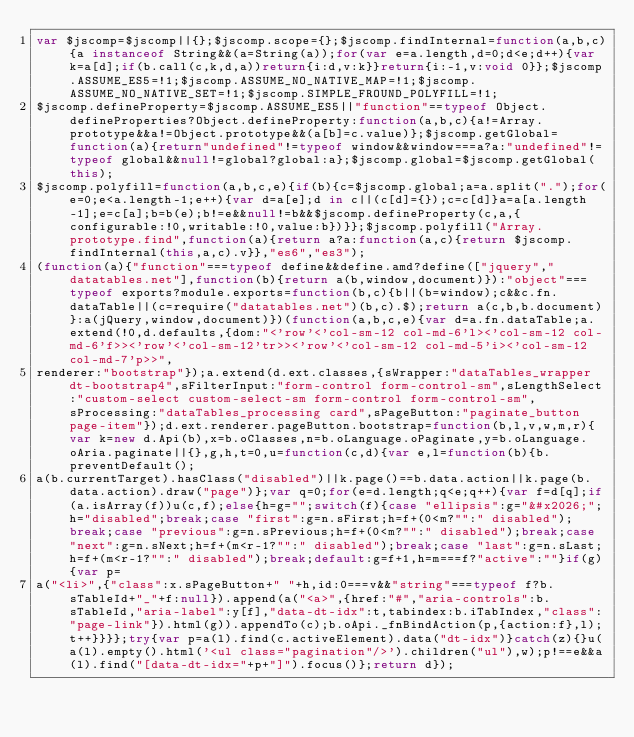<code> <loc_0><loc_0><loc_500><loc_500><_JavaScript_>var $jscomp=$jscomp||{};$jscomp.scope={};$jscomp.findInternal=function(a,b,c){a instanceof String&&(a=String(a));for(var e=a.length,d=0;d<e;d++){var k=a[d];if(b.call(c,k,d,a))return{i:d,v:k}}return{i:-1,v:void 0}};$jscomp.ASSUME_ES5=!1;$jscomp.ASSUME_NO_NATIVE_MAP=!1;$jscomp.ASSUME_NO_NATIVE_SET=!1;$jscomp.SIMPLE_FROUND_POLYFILL=!1;
$jscomp.defineProperty=$jscomp.ASSUME_ES5||"function"==typeof Object.defineProperties?Object.defineProperty:function(a,b,c){a!=Array.prototype&&a!=Object.prototype&&(a[b]=c.value)};$jscomp.getGlobal=function(a){return"undefined"!=typeof window&&window===a?a:"undefined"!=typeof global&&null!=global?global:a};$jscomp.global=$jscomp.getGlobal(this);
$jscomp.polyfill=function(a,b,c,e){if(b){c=$jscomp.global;a=a.split(".");for(e=0;e<a.length-1;e++){var d=a[e];d in c||(c[d]={});c=c[d]}a=a[a.length-1];e=c[a];b=b(e);b!=e&&null!=b&&$jscomp.defineProperty(c,a,{configurable:!0,writable:!0,value:b})}};$jscomp.polyfill("Array.prototype.find",function(a){return a?a:function(a,c){return $jscomp.findInternal(this,a,c).v}},"es6","es3");
(function(a){"function"===typeof define&&define.amd?define(["jquery","datatables.net"],function(b){return a(b,window,document)}):"object"===typeof exports?module.exports=function(b,c){b||(b=window);c&&c.fn.dataTable||(c=require("datatables.net")(b,c).$);return a(c,b,b.document)}:a(jQuery,window,document)})(function(a,b,c,e){var d=a.fn.dataTable;a.extend(!0,d.defaults,{dom:"<'row'<'col-sm-12 col-md-6'l><'col-sm-12 col-md-6'f>><'row'<'col-sm-12'tr>><'row'<'col-sm-12 col-md-5'i><'col-sm-12 col-md-7'p>>",
renderer:"bootstrap"});a.extend(d.ext.classes,{sWrapper:"dataTables_wrapper dt-bootstrap4",sFilterInput:"form-control form-control-sm",sLengthSelect:"custom-select custom-select-sm form-control form-control-sm",sProcessing:"dataTables_processing card",sPageButton:"paginate_button page-item"});d.ext.renderer.pageButton.bootstrap=function(b,l,v,w,m,r){var k=new d.Api(b),x=b.oClasses,n=b.oLanguage.oPaginate,y=b.oLanguage.oAria.paginate||{},g,h,t=0,u=function(c,d){var e,l=function(b){b.preventDefault();
a(b.currentTarget).hasClass("disabled")||k.page()==b.data.action||k.page(b.data.action).draw("page")};var q=0;for(e=d.length;q<e;q++){var f=d[q];if(a.isArray(f))u(c,f);else{h=g="";switch(f){case "ellipsis":g="&#x2026;";h="disabled";break;case "first":g=n.sFirst;h=f+(0<m?"":" disabled");break;case "previous":g=n.sPrevious;h=f+(0<m?"":" disabled");break;case "next":g=n.sNext;h=f+(m<r-1?"":" disabled");break;case "last":g=n.sLast;h=f+(m<r-1?"":" disabled");break;default:g=f+1,h=m===f?"active":""}if(g){var p=
a("<li>",{"class":x.sPageButton+" "+h,id:0===v&&"string"===typeof f?b.sTableId+"_"+f:null}).append(a("<a>",{href:"#","aria-controls":b.sTableId,"aria-label":y[f],"data-dt-idx":t,tabindex:b.iTabIndex,"class":"page-link"}).html(g)).appendTo(c);b.oApi._fnBindAction(p,{action:f},l);t++}}}};try{var p=a(l).find(c.activeElement).data("dt-idx")}catch(z){}u(a(l).empty().html('<ul class="pagination"/>').children("ul"),w);p!==e&&a(l).find("[data-dt-idx="+p+"]").focus()};return d});</code> 